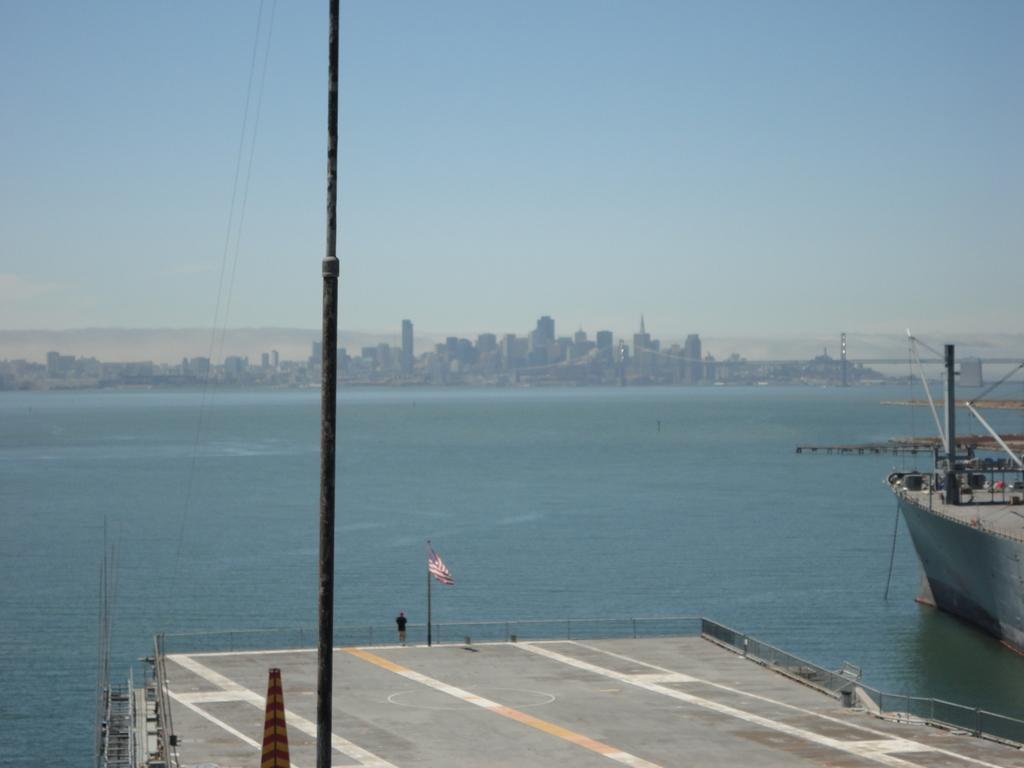In one or two sentences, can you explain what this image depicts? In this image we can see a person standing on a runway beside to him there is a flag placed on the pole. In the background we can see a ship on the water ,group of buildings and sky. 